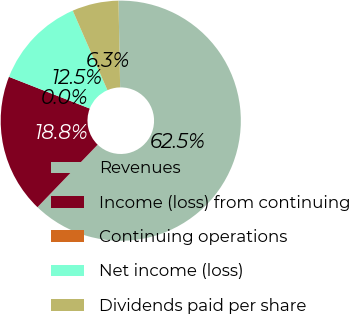<chart> <loc_0><loc_0><loc_500><loc_500><pie_chart><fcel>Revenues<fcel>Income (loss) from continuing<fcel>Continuing operations<fcel>Net income (loss)<fcel>Dividends paid per share<nl><fcel>62.49%<fcel>18.75%<fcel>0.0%<fcel>12.5%<fcel>6.25%<nl></chart> 